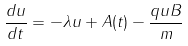<formula> <loc_0><loc_0><loc_500><loc_500>\frac { d u } { d t } = - { \lambda } u + A ( t ) - \frac { q u B } { m }</formula> 